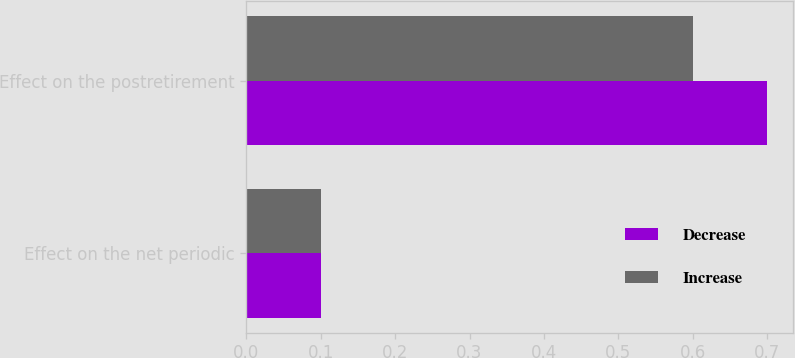Convert chart. <chart><loc_0><loc_0><loc_500><loc_500><stacked_bar_chart><ecel><fcel>Effect on the net periodic<fcel>Effect on the postretirement<nl><fcel>Decrease<fcel>0.1<fcel>0.7<nl><fcel>Increase<fcel>0.1<fcel>0.6<nl></chart> 